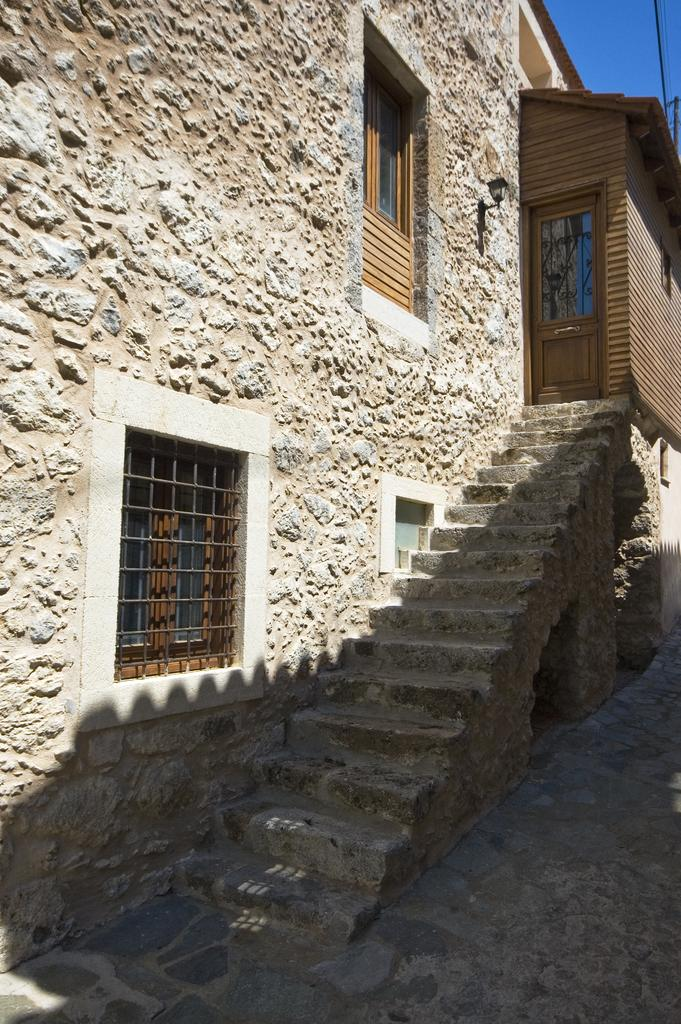What type of structures can be seen in the image? There are buildings in the image. What architectural feature is present in the buildings? There are stairs to climb in the image. What can be seen in the walls of the buildings? There are windows in the walls of the buildings. Where is a light source located in the image? A light is fixed to a wall in the image. What color is the sky in the image? The sky is blue in the image. How many legs does the building have in the image? Buildings do not have legs; they are stationary structures. 